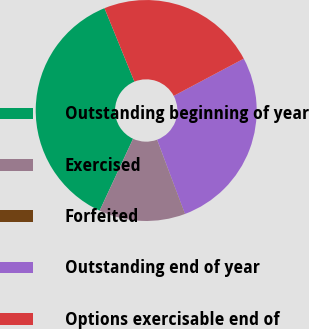Convert chart to OTSL. <chart><loc_0><loc_0><loc_500><loc_500><pie_chart><fcel>Outstanding beginning of year<fcel>Exercised<fcel>Forfeited<fcel>Outstanding end of year<fcel>Options exercisable end of<nl><fcel>36.91%<fcel>12.56%<fcel>0.06%<fcel>27.07%<fcel>23.39%<nl></chart> 